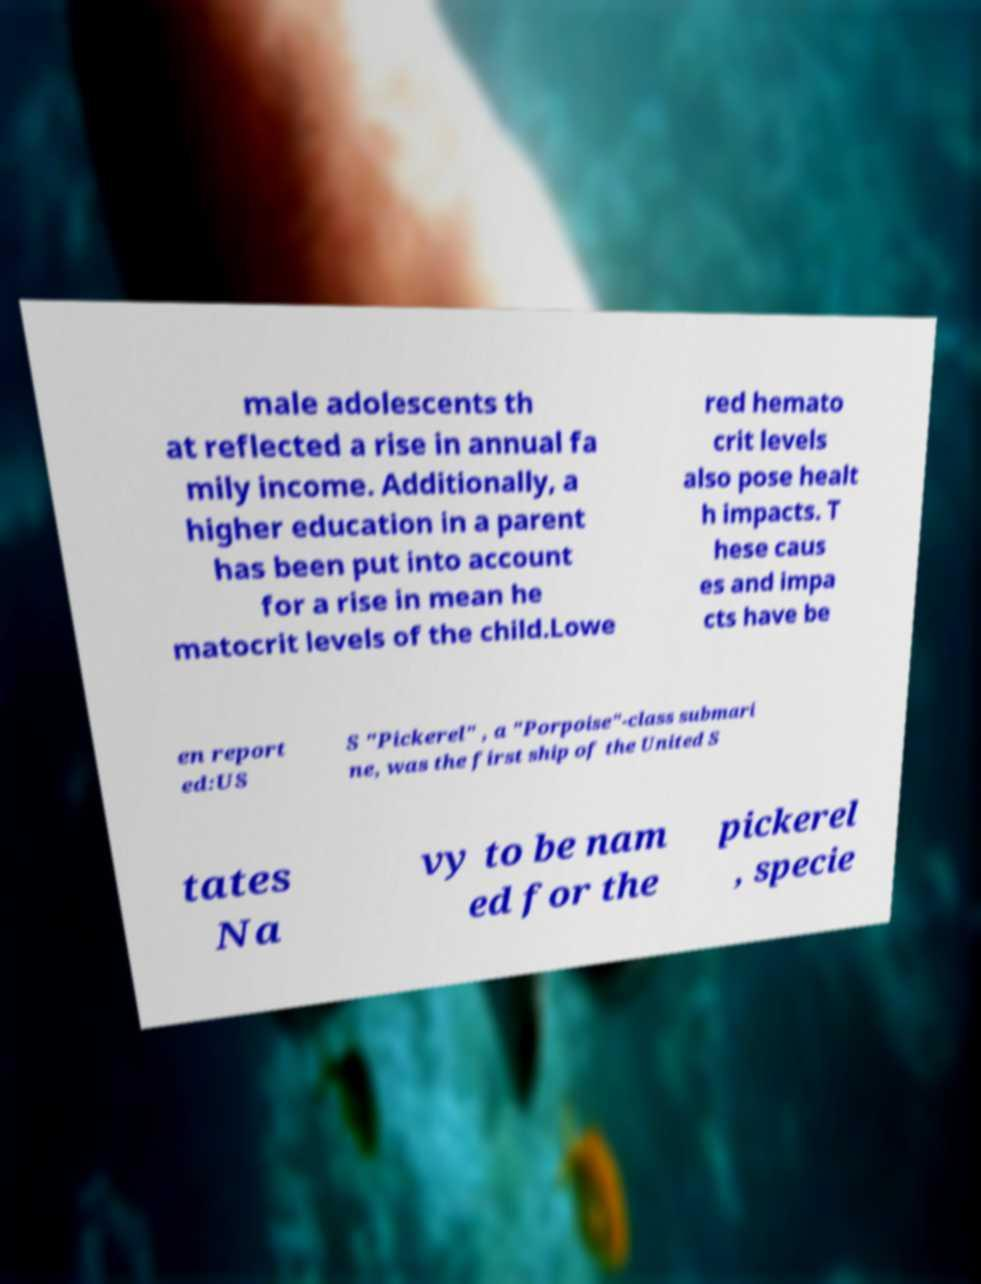What messages or text are displayed in this image? I need them in a readable, typed format. male adolescents th at reflected a rise in annual fa mily income. Additionally, a higher education in a parent has been put into account for a rise in mean he matocrit levels of the child.Lowe red hemato crit levels also pose healt h impacts. T hese caus es and impa cts have be en report ed:US S "Pickerel" , a "Porpoise"-class submari ne, was the first ship of the United S tates Na vy to be nam ed for the pickerel , specie 